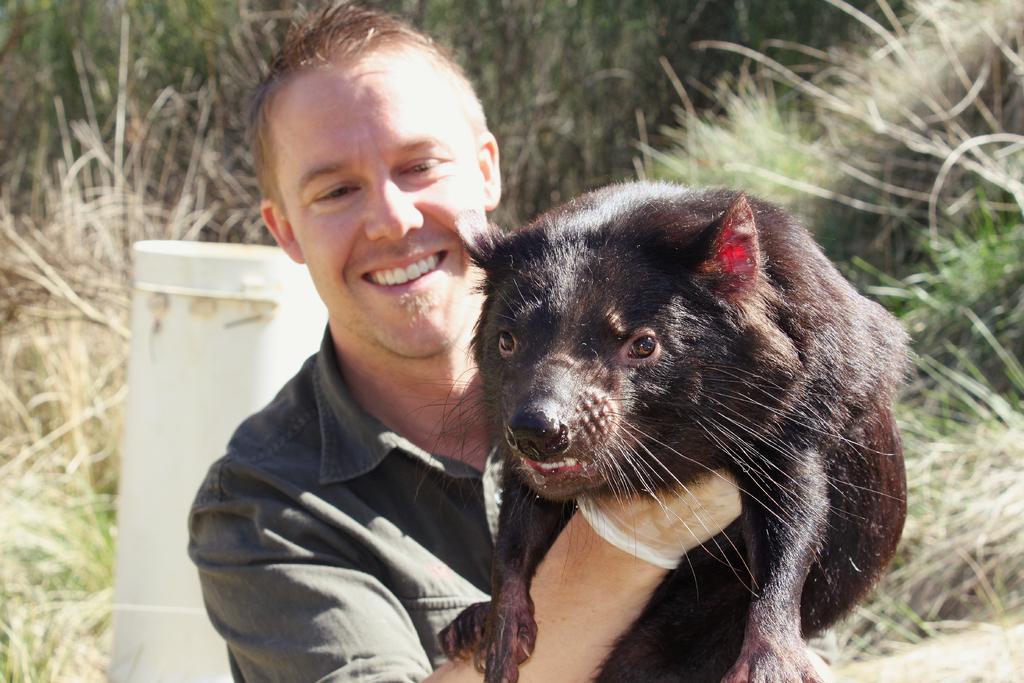Please provide a concise description of this image. In this picture there is a person holding a black color animal in his hands and there is greenery grass behind him. 